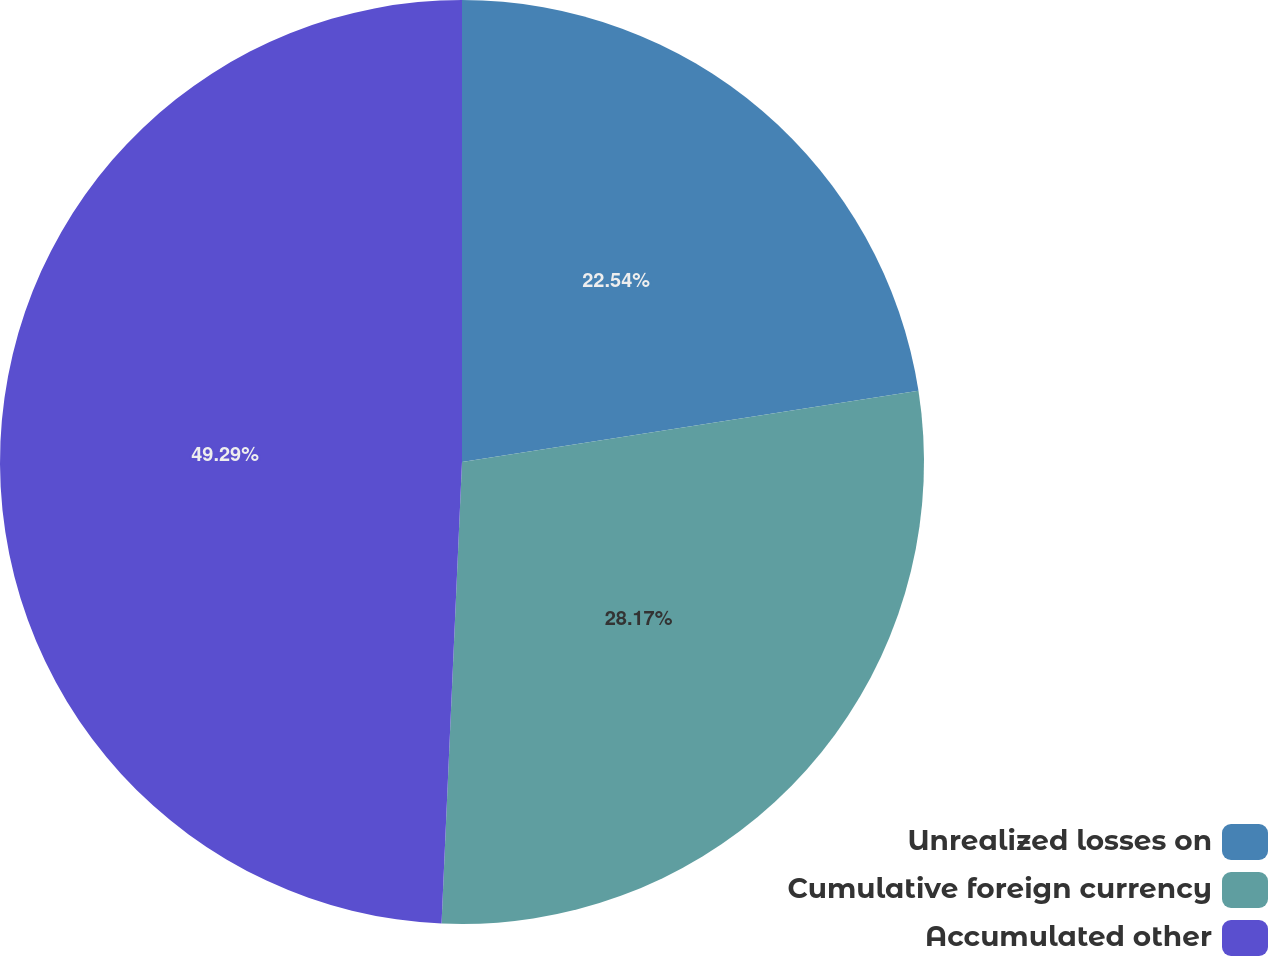Convert chart. <chart><loc_0><loc_0><loc_500><loc_500><pie_chart><fcel>Unrealized losses on<fcel>Cumulative foreign currency<fcel>Accumulated other<nl><fcel>22.54%<fcel>28.17%<fcel>49.3%<nl></chart> 